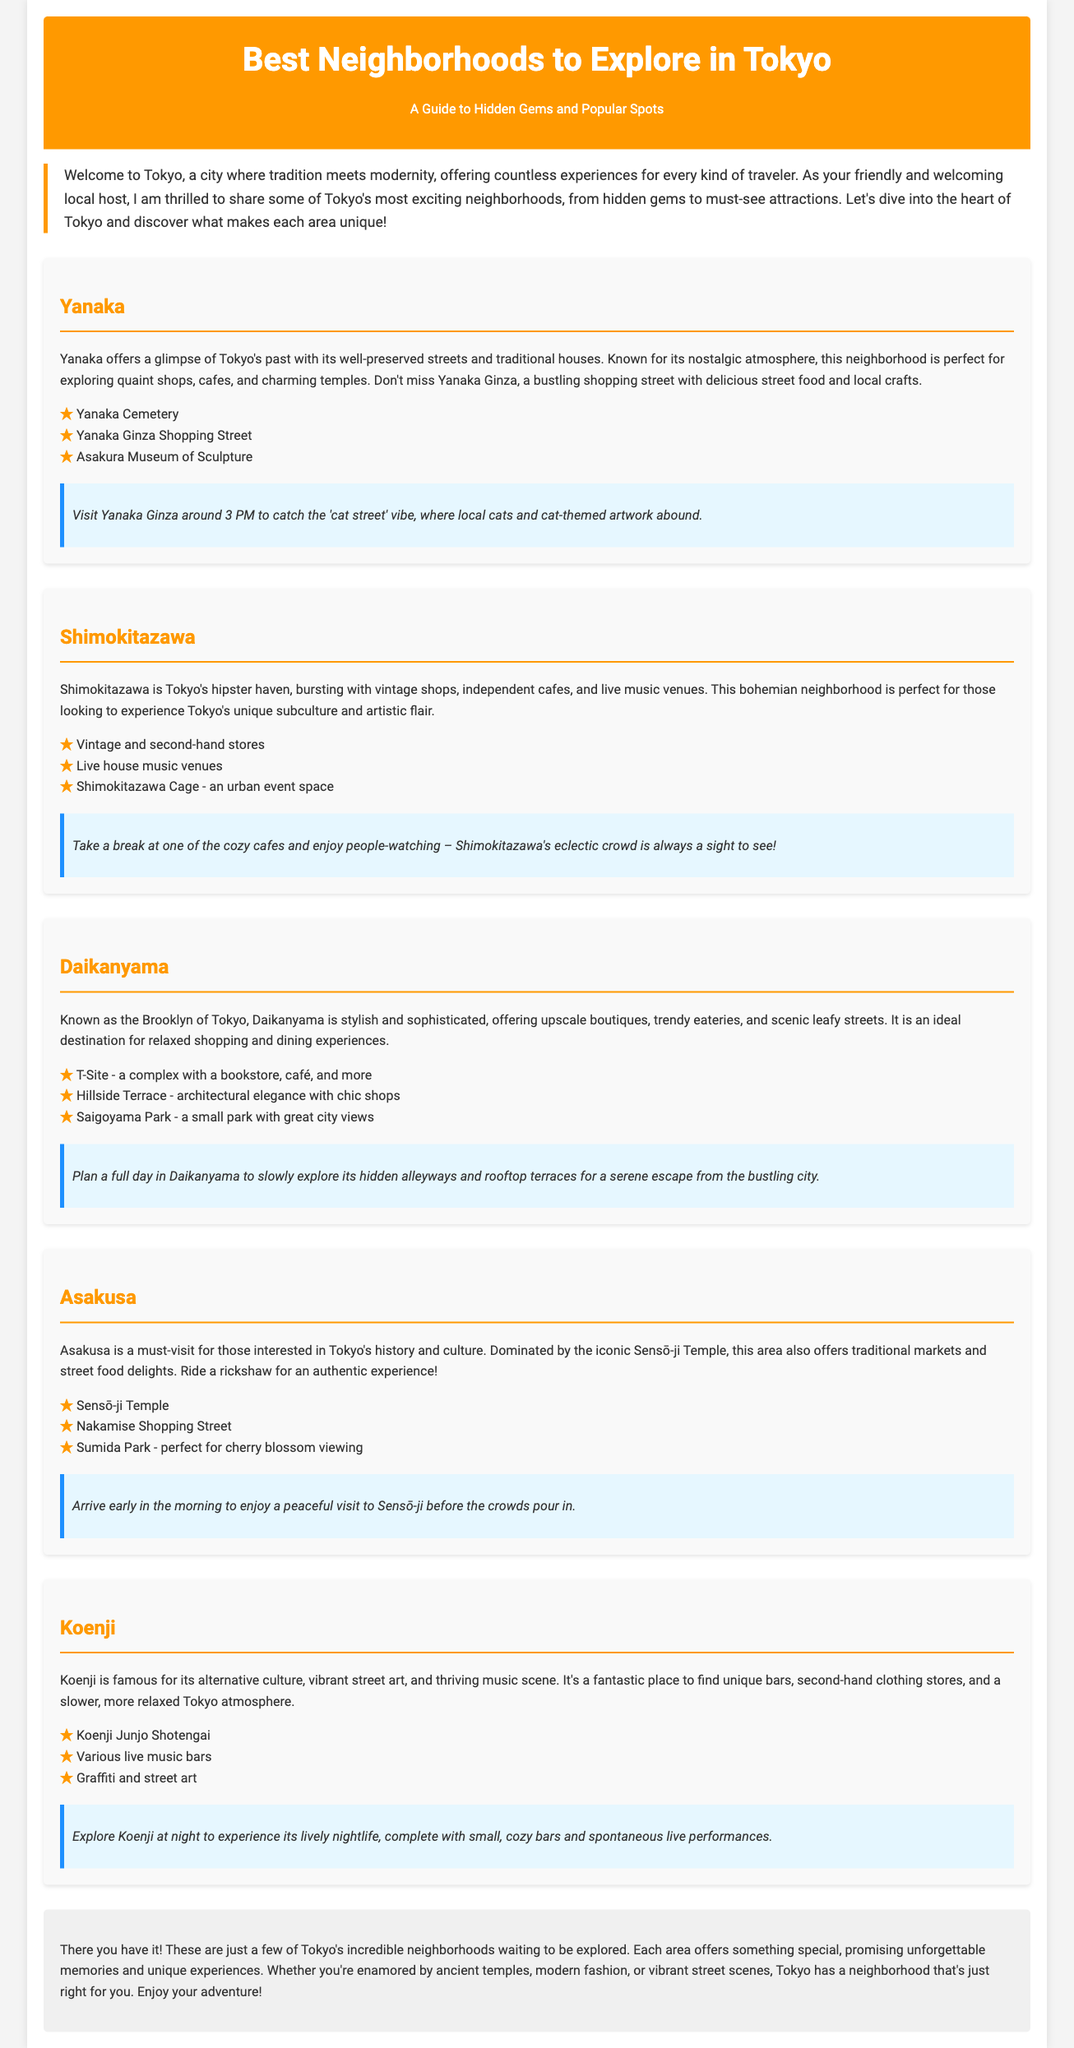What is the title of the document? The title is presented in the header section of the document.
Answer: Best Neighborhoods to Explore in Tokyo How many neighborhoods are described in the document? The document lists five neighborhoods, each with its own section.
Answer: Five What is one highlight of Yanaka? Each neighborhood section contains a list of highlights.
Answer: Yanaka Cemetery Which neighborhood is known as the "Brooklyn of Tokyo"? The document specifically refers to one neighborhood with this nickname.
Answer: Daikanyama What is the insider tip for Asakusa? Each neighborhood has an insider tip that provides specific advice for visitors.
Answer: Arrive early in the morning to enjoy a peaceful visit to Sensō-ji before the crowds pour in What type of atmosphere does Shimokitazawa have? The description of Shimokitazawa illustrates its unique character.
Answer: Hipster haven What popular activity is suggested for visitors to Koenji? The document includes recommendations for experiencing each neighborhood.
Answer: Experience its lively nightlife What is the background color of the header? The style information for the header indicates its background color.
Answer: Orange 